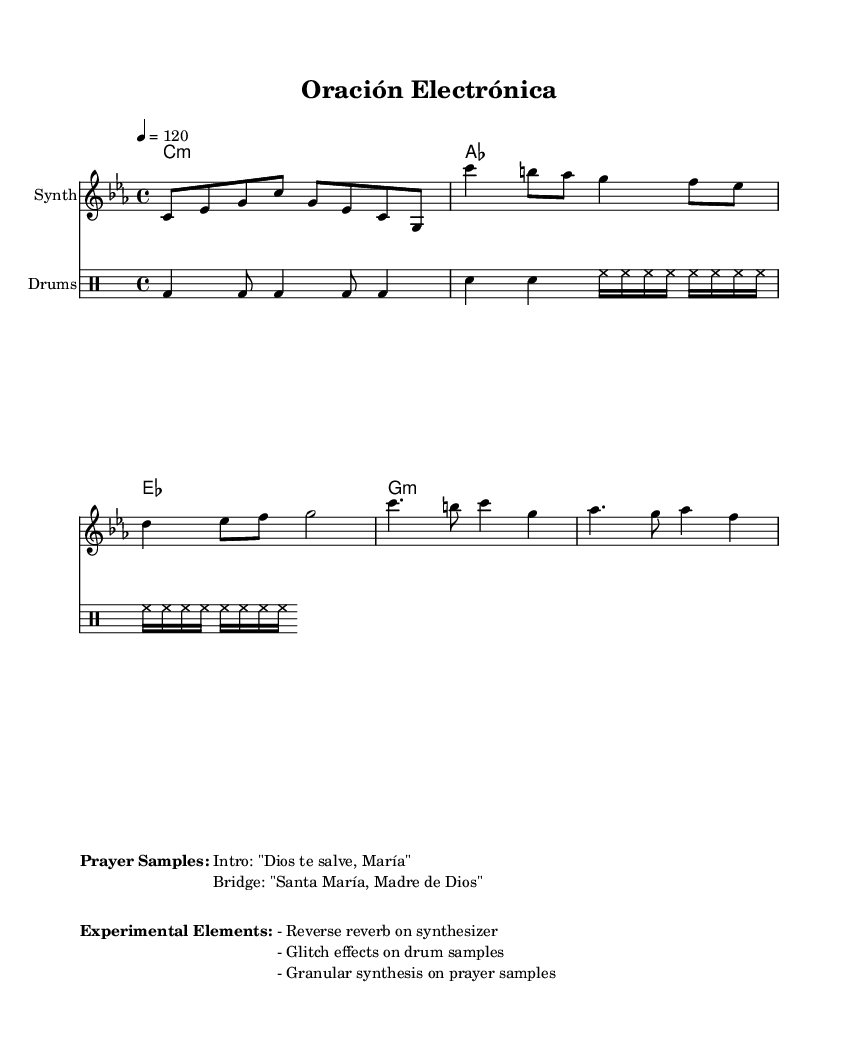What is the key signature of this music? The key signature is C minor, which has three flats (B♭, E♭, A♭). This can be identified at the beginning of the score where the key signature is notated.
Answer: C minor What is the time signature of the piece? The time signature is 4/4, indicated at the beginning of the score. This shows that there are four beats in each measure, and a quarter note gets one beat.
Answer: 4/4 What is the tempo marking of the piece? The tempo marking is set to 120 beats per minute, as indicated by the tempo directive written in the score. This guides the speed of the performance.
Answer: 120 How many total measures are in the synthesizer part? By counting the measures notated in the synthesizer part, there are a total of 6 measures which can be seen in the standard four-bar structure of the intro, verse, and chorus.
Answer: 6 What is the first vocal sample mentioned in the piece? The first vocal sample written in the score is "Dios te salve, María," which is noted under the section titled "Prayer Samples." This indicates the integration of prayer samples into the electronic music structure.
Answer: Dios te salve, María What type of synthesis is applied to the prayer samples? The score notes that "granular synthesis" is used on the prayer samples, which suggests a specific electronic music technique that manipulates sound by dividing it into small segments.
Answer: Granular synthesis What type of drum effects are suggested in this piece? The score mentions "glitch effects on drum samples," which indicates a specific electronic music technique that introduces unexpected sounds or rhythmic shifts, contributing to the experimental nature of this piece.
Answer: Glitch effects 